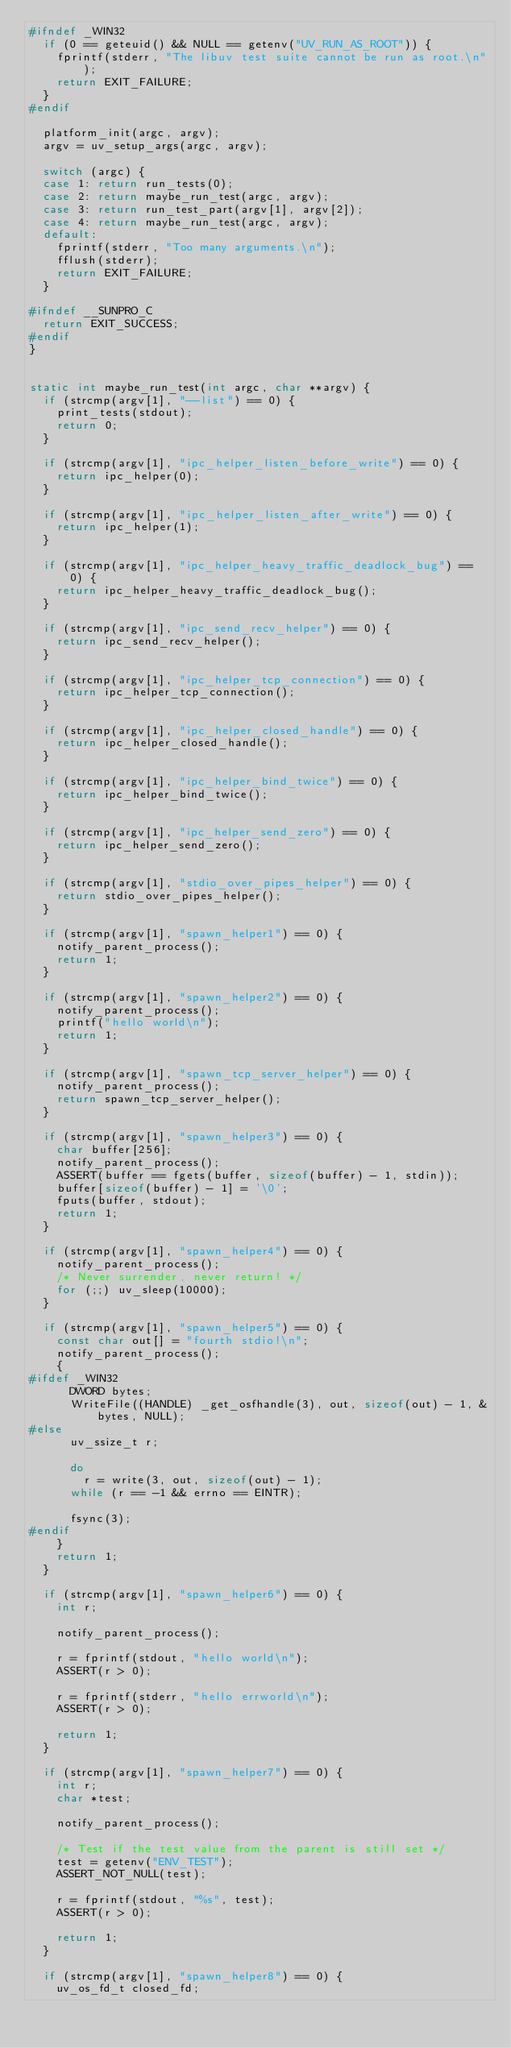Convert code to text. <code><loc_0><loc_0><loc_500><loc_500><_C_>#ifndef _WIN32
  if (0 == geteuid() && NULL == getenv("UV_RUN_AS_ROOT")) {
    fprintf(stderr, "The libuv test suite cannot be run as root.\n");
    return EXIT_FAILURE;
  }
#endif

  platform_init(argc, argv);
  argv = uv_setup_args(argc, argv);

  switch (argc) {
  case 1: return run_tests(0);
  case 2: return maybe_run_test(argc, argv);
  case 3: return run_test_part(argv[1], argv[2]);
  case 4: return maybe_run_test(argc, argv);
  default:
    fprintf(stderr, "Too many arguments.\n");
    fflush(stderr);
    return EXIT_FAILURE;
  }

#ifndef __SUNPRO_C
  return EXIT_SUCCESS;
#endif
}


static int maybe_run_test(int argc, char **argv) {
  if (strcmp(argv[1], "--list") == 0) {
    print_tests(stdout);
    return 0;
  }

  if (strcmp(argv[1], "ipc_helper_listen_before_write") == 0) {
    return ipc_helper(0);
  }

  if (strcmp(argv[1], "ipc_helper_listen_after_write") == 0) {
    return ipc_helper(1);
  }

  if (strcmp(argv[1], "ipc_helper_heavy_traffic_deadlock_bug") == 0) {
    return ipc_helper_heavy_traffic_deadlock_bug();
  }

  if (strcmp(argv[1], "ipc_send_recv_helper") == 0) {
    return ipc_send_recv_helper();
  }

  if (strcmp(argv[1], "ipc_helper_tcp_connection") == 0) {
    return ipc_helper_tcp_connection();
  }

  if (strcmp(argv[1], "ipc_helper_closed_handle") == 0) {
    return ipc_helper_closed_handle();
  }

  if (strcmp(argv[1], "ipc_helper_bind_twice") == 0) {
    return ipc_helper_bind_twice();
  }

  if (strcmp(argv[1], "ipc_helper_send_zero") == 0) {
    return ipc_helper_send_zero();
  }

  if (strcmp(argv[1], "stdio_over_pipes_helper") == 0) {
    return stdio_over_pipes_helper();
  }

  if (strcmp(argv[1], "spawn_helper1") == 0) {
    notify_parent_process();
    return 1;
  }

  if (strcmp(argv[1], "spawn_helper2") == 0) {
    notify_parent_process();
    printf("hello world\n");
    return 1;
  }

  if (strcmp(argv[1], "spawn_tcp_server_helper") == 0) {
    notify_parent_process();
    return spawn_tcp_server_helper();
  }

  if (strcmp(argv[1], "spawn_helper3") == 0) {
    char buffer[256];
    notify_parent_process();
    ASSERT(buffer == fgets(buffer, sizeof(buffer) - 1, stdin));
    buffer[sizeof(buffer) - 1] = '\0';
    fputs(buffer, stdout);
    return 1;
  }

  if (strcmp(argv[1], "spawn_helper4") == 0) {
    notify_parent_process();
    /* Never surrender, never return! */
    for (;;) uv_sleep(10000);
  }

  if (strcmp(argv[1], "spawn_helper5") == 0) {
    const char out[] = "fourth stdio!\n";
    notify_parent_process();
    {
#ifdef _WIN32
      DWORD bytes;
      WriteFile((HANDLE) _get_osfhandle(3), out, sizeof(out) - 1, &bytes, NULL);
#else
      uv_ssize_t r;

      do
        r = write(3, out, sizeof(out) - 1);
      while (r == -1 && errno == EINTR);

      fsync(3);
#endif
    }
    return 1;
  }

  if (strcmp(argv[1], "spawn_helper6") == 0) {
    int r;

    notify_parent_process();

    r = fprintf(stdout, "hello world\n");
    ASSERT(r > 0);

    r = fprintf(stderr, "hello errworld\n");
    ASSERT(r > 0);

    return 1;
  }

  if (strcmp(argv[1], "spawn_helper7") == 0) {
    int r;
    char *test;

    notify_parent_process();

    /* Test if the test value from the parent is still set */
    test = getenv("ENV_TEST");
    ASSERT_NOT_NULL(test);

    r = fprintf(stdout, "%s", test);
    ASSERT(r > 0);

    return 1;
  }

  if (strcmp(argv[1], "spawn_helper8") == 0) {
    uv_os_fd_t closed_fd;</code> 